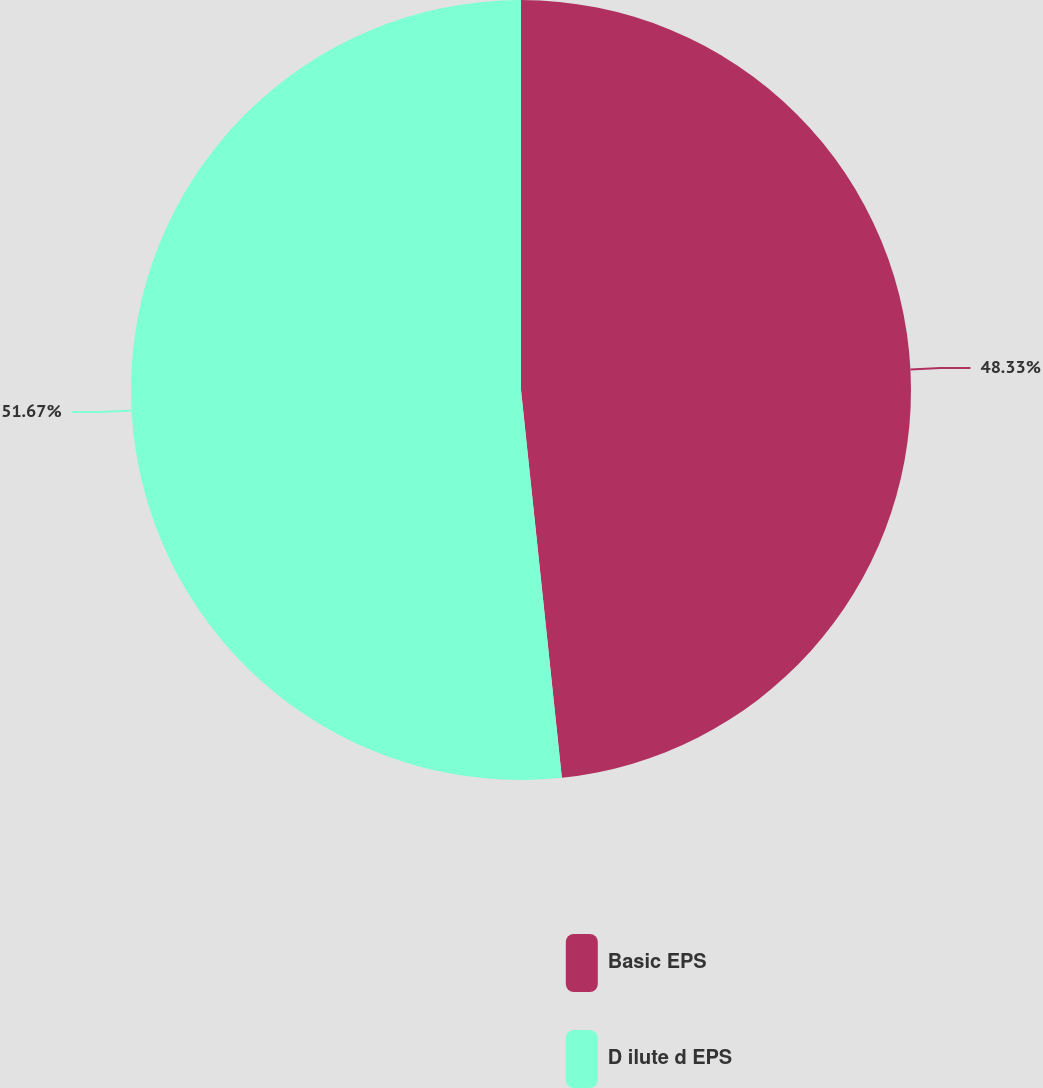<chart> <loc_0><loc_0><loc_500><loc_500><pie_chart><fcel>Basic EPS<fcel>D ilute d EPS<nl><fcel>48.33%<fcel>51.67%<nl></chart> 